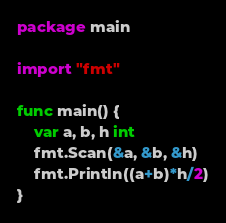Convert code to text. <code><loc_0><loc_0><loc_500><loc_500><_Go_>package main

import "fmt"

func main() {
	var a, b, h int
	fmt.Scan(&a, &b, &h)
	fmt.Println((a+b)*h/2)
}
</code> 